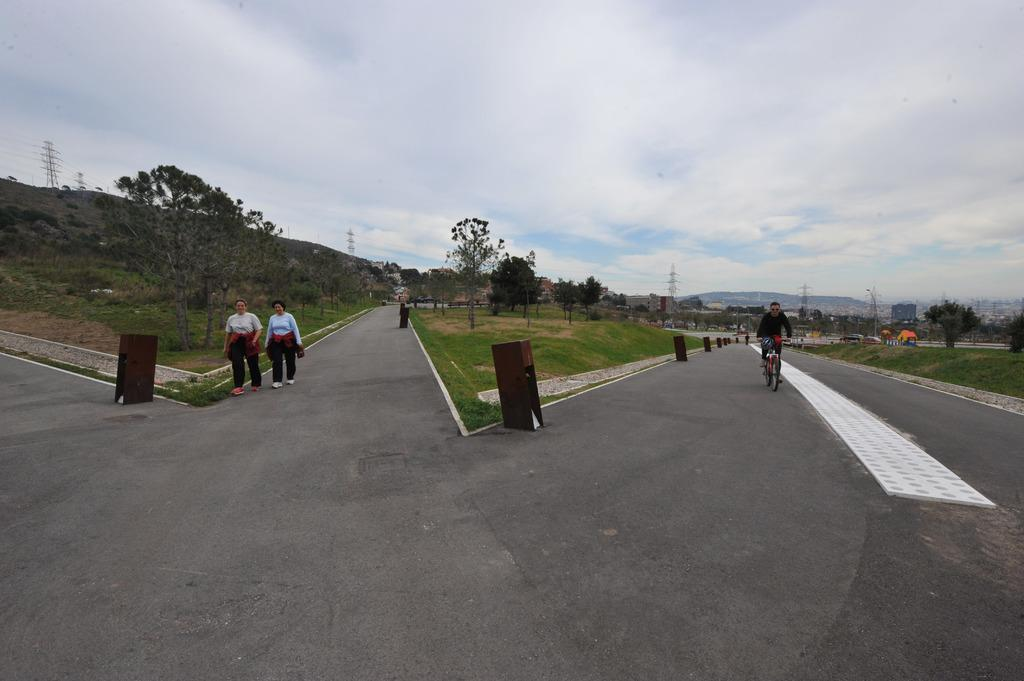How many persons can be seen in the image? There are persons in the image, but the exact number is not specified. What type of natural vegetation is present in the image? There are trees in the image. What type of waste disposal units are visible in the image? Dustbins are present in the image. What type of pathway is visible in the image? There is a road in the image. What type of tall structures can be seen in the image? There are towers in the image. What type of temporary shelters are visible in the image? Tents are visible in the image. What part of the natural environment is visible in the image? The sky is visible in the image. What type of atmospheric phenomena can be seen in the sky? Clouds are present in the sky. What type of brain can be seen in the image? There is no brain present in the image. What type of books can be seen in the image? There is no mention of books in the image. What type of furniture can be seen in the image? There is no furniture present in the image. 